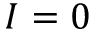<formula> <loc_0><loc_0><loc_500><loc_500>I = 0</formula> 